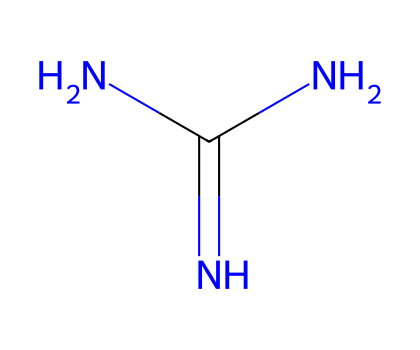What is the molecular formula of guanidine? The SMILES representation indicates the presence of two nitrogen atoms, one carbon atom, and three hydrogen atoms, leading to the molecular formula being C1H7N5.
Answer: C1H7N5 How many nitrogen atoms are in guanidine? By analyzing the SMILES representation, we can observe that there are three nitrogen atoms (N) present in the structure.
Answer: 3 What type of functional groups does guanidine contain? The presence of primary amine (NH2) and imine (C=N) functional groups can be identified in the chemical structure of guanidine, which contributes to its basic properties.
Answer: amine and imine What is the basicity level of guanidine? Guanidine is classified as a strong organic superbase due to its ability to donate a proton easily, making it much more basic than regular amines.
Answer: strong superbase What is the hybridization of the carbon atom in guanidine? The carbon atom in guanidine is connected to two nitrogen atoms and has a double bond with one nitrogen, implying that it is sp² hybridized because it is involved in a trigonal planar arrangement.
Answer: sp² How does the structure of guanidine contribute to its superbase properties? Guanidine's resonance stabilization due to the delocalization of electrons between multiple nitrogen atoms enhances its basicity, allowing it to accept protons more easily compared to weaker bases.
Answer: resonance stabilization 